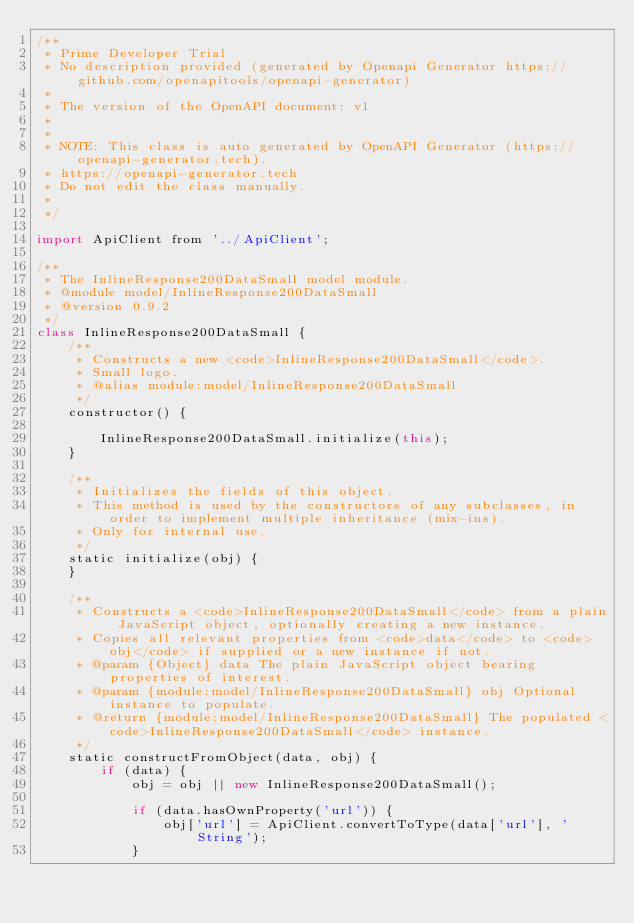<code> <loc_0><loc_0><loc_500><loc_500><_JavaScript_>/**
 * Prime Developer Trial
 * No description provided (generated by Openapi Generator https://github.com/openapitools/openapi-generator)
 *
 * The version of the OpenAPI document: v1
 * 
 *
 * NOTE: This class is auto generated by OpenAPI Generator (https://openapi-generator.tech).
 * https://openapi-generator.tech
 * Do not edit the class manually.
 *
 */

import ApiClient from '../ApiClient';

/**
 * The InlineResponse200DataSmall model module.
 * @module model/InlineResponse200DataSmall
 * @version 0.9.2
 */
class InlineResponse200DataSmall {
    /**
     * Constructs a new <code>InlineResponse200DataSmall</code>.
     * Small logo.
     * @alias module:model/InlineResponse200DataSmall
     */
    constructor() { 
        
        InlineResponse200DataSmall.initialize(this);
    }

    /**
     * Initializes the fields of this object.
     * This method is used by the constructors of any subclasses, in order to implement multiple inheritance (mix-ins).
     * Only for internal use.
     */
    static initialize(obj) { 
    }

    /**
     * Constructs a <code>InlineResponse200DataSmall</code> from a plain JavaScript object, optionally creating a new instance.
     * Copies all relevant properties from <code>data</code> to <code>obj</code> if supplied or a new instance if not.
     * @param {Object} data The plain JavaScript object bearing properties of interest.
     * @param {module:model/InlineResponse200DataSmall} obj Optional instance to populate.
     * @return {module:model/InlineResponse200DataSmall} The populated <code>InlineResponse200DataSmall</code> instance.
     */
    static constructFromObject(data, obj) {
        if (data) {
            obj = obj || new InlineResponse200DataSmall();

            if (data.hasOwnProperty('url')) {
                obj['url'] = ApiClient.convertToType(data['url'], 'String');
            }</code> 